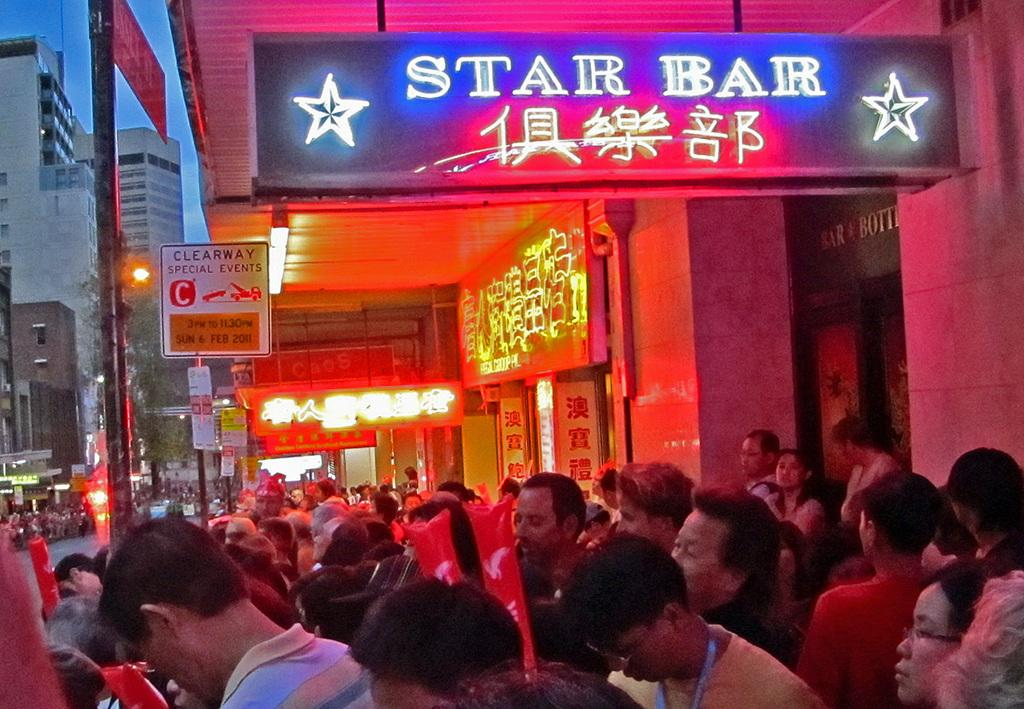How many people are in the image? There is a group of people in the image, but the exact number cannot be determined from the provided facts. What can be seen in the image besides the group of people? There are posts, name boards, buildings, and the sky visible in the image. What might the name boards be used for? The name boards might be used to identify or label the buildings or areas in the image. What is visible at the top of the image? The sky is visible at the top of the image. What type of music can be heard playing in the background of the image? There is no information about music or any sounds in the image, so it cannot be determined from the provided facts. 